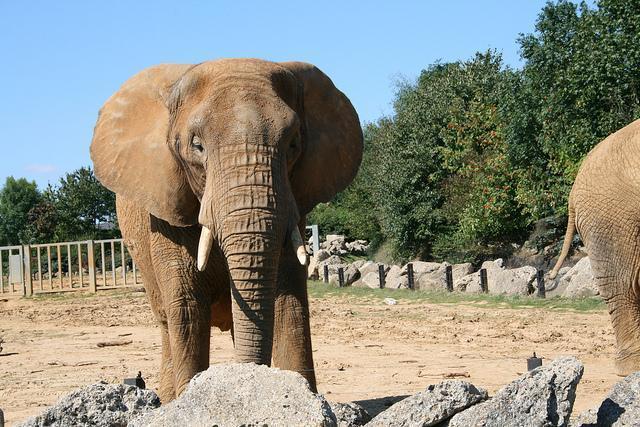How many elephants can be seen?
Give a very brief answer. 2. 